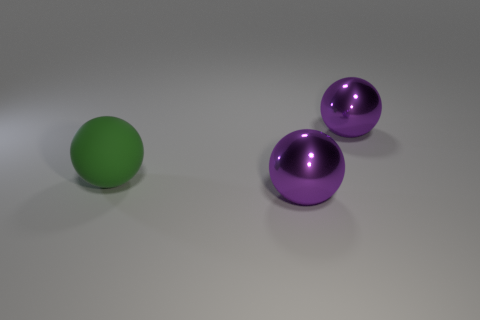What materials do the objects in the image seem to be made of? The objects in the image have a smooth, reflective surface, suggesting they could be made of polished plastic or a metal like polished aluminum. 